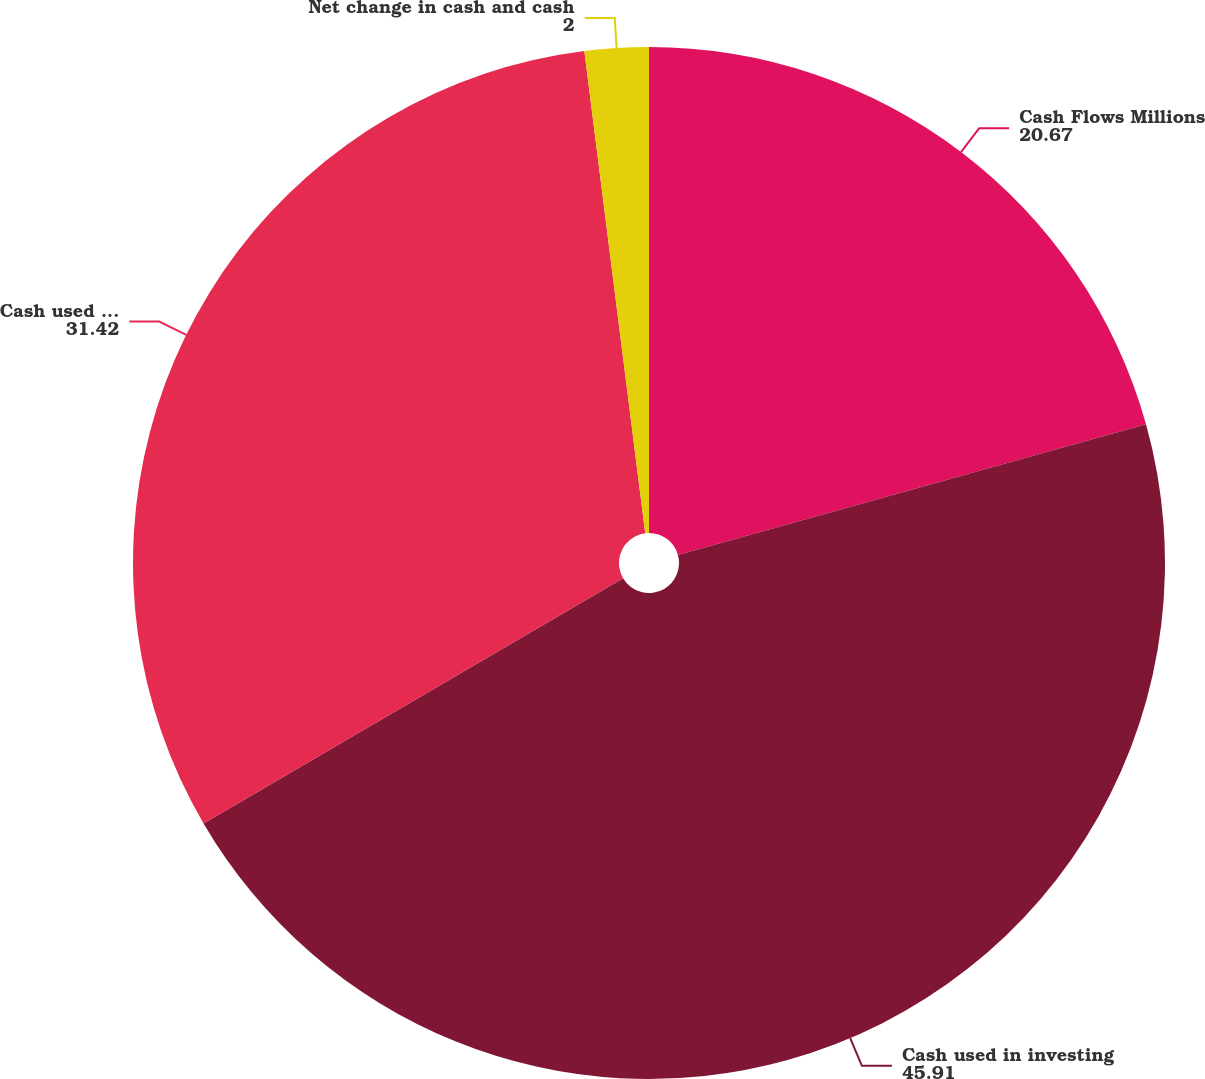Convert chart to OTSL. <chart><loc_0><loc_0><loc_500><loc_500><pie_chart><fcel>Cash Flows Millions<fcel>Cash used in investing<fcel>Cash used in financing<fcel>Net change in cash and cash<nl><fcel>20.67%<fcel>45.91%<fcel>31.42%<fcel>2.0%<nl></chart> 